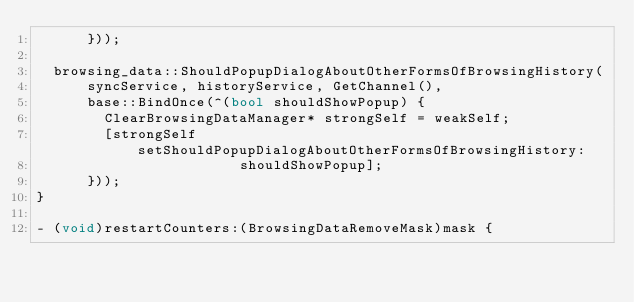Convert code to text. <code><loc_0><loc_0><loc_500><loc_500><_ObjectiveC_>      }));

  browsing_data::ShouldPopupDialogAboutOtherFormsOfBrowsingHistory(
      syncService, historyService, GetChannel(),
      base::BindOnce(^(bool shouldShowPopup) {
        ClearBrowsingDataManager* strongSelf = weakSelf;
        [strongSelf setShouldPopupDialogAboutOtherFormsOfBrowsingHistory:
                        shouldShowPopup];
      }));
}

- (void)restartCounters:(BrowsingDataRemoveMask)mask {</code> 